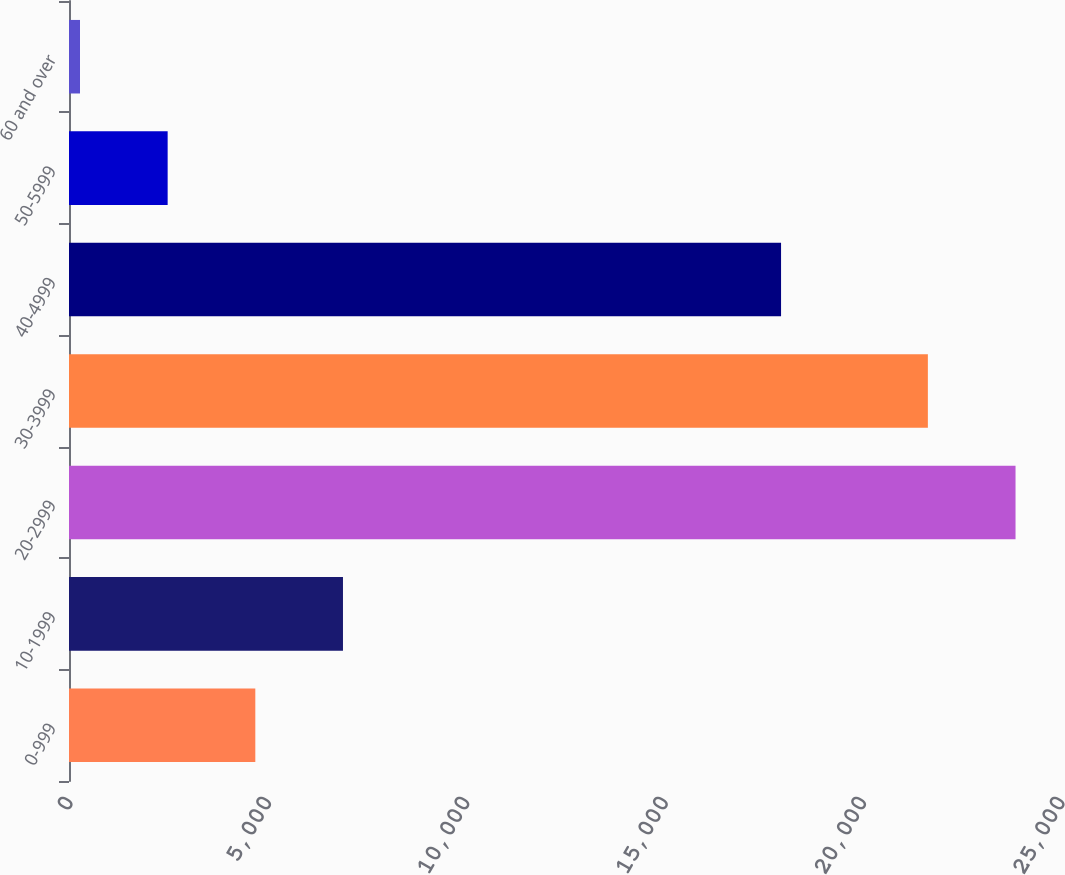Convert chart. <chart><loc_0><loc_0><loc_500><loc_500><bar_chart><fcel>0-999<fcel>10-1999<fcel>20-2999<fcel>30-3999<fcel>40-4999<fcel>50-5999<fcel>60 and over<nl><fcel>4695.4<fcel>6904.6<fcel>23854.2<fcel>21645<fcel>17945<fcel>2486.2<fcel>277<nl></chart> 